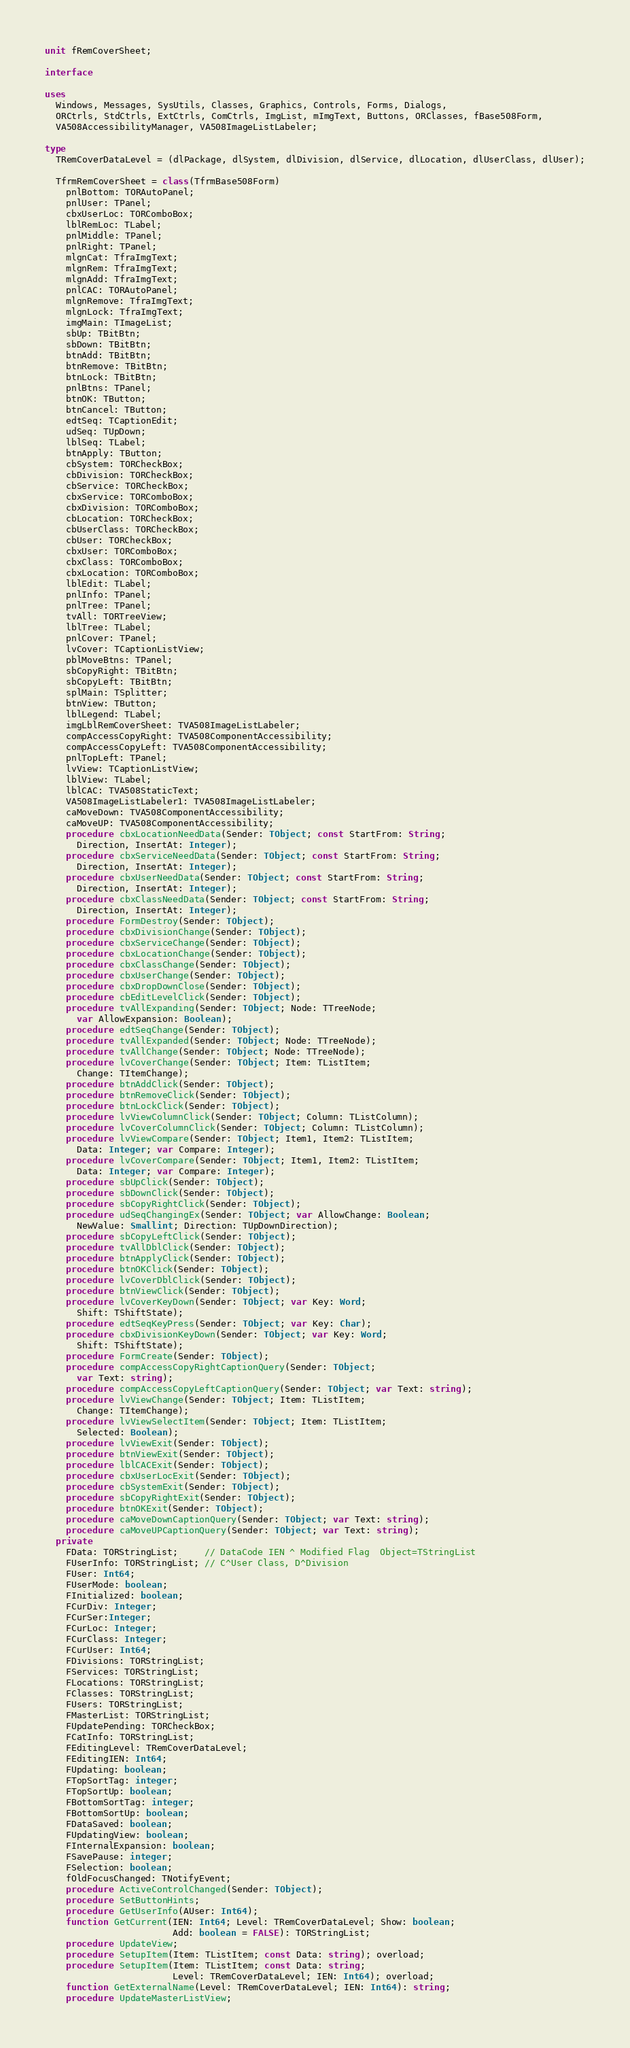Convert code to text. <code><loc_0><loc_0><loc_500><loc_500><_Pascal_>unit fRemCoverSheet;

interface

uses
  Windows, Messages, SysUtils, Classes, Graphics, Controls, Forms, Dialogs,
  ORCtrls, StdCtrls, ExtCtrls, ComCtrls, ImgList, mImgText, Buttons, ORClasses, fBase508Form,
  VA508AccessibilityManager, VA508ImageListLabeler;

type
  TRemCoverDataLevel = (dlPackage, dlSystem, dlDivision, dlService, dlLocation, dlUserClass, dlUser);

  TfrmRemCoverSheet = class(TfrmBase508Form)
    pnlBottom: TORAutoPanel;
    pnlUser: TPanel;
    cbxUserLoc: TORComboBox;
    lblRemLoc: TLabel;
    pnlMiddle: TPanel;
    pnlRight: TPanel;
    mlgnCat: TfraImgText;
    mlgnRem: TfraImgText;
    mlgnAdd: TfraImgText;
    pnlCAC: TORAutoPanel;
    mlgnRemove: TfraImgText;
    mlgnLock: TfraImgText;
    imgMain: TImageList;
    sbUp: TBitBtn;
    sbDown: TBitBtn;
    btnAdd: TBitBtn;
    btnRemove: TBitBtn;
    btnLock: TBitBtn;
    pnlBtns: TPanel;
    btnOK: TButton;
    btnCancel: TButton;
    edtSeq: TCaptionEdit;
    udSeq: TUpDown;
    lblSeq: TLabel;
    btnApply: TButton;
    cbSystem: TORCheckBox;
    cbDivision: TORCheckBox;
    cbService: TORCheckBox;
    cbxService: TORComboBox;
    cbxDivision: TORComboBox;
    cbLocation: TORCheckBox;
    cbUserClass: TORCheckBox;
    cbUser: TORCheckBox;
    cbxUser: TORComboBox;
    cbxClass: TORComboBox;
    cbxLocation: TORComboBox;
    lblEdit: TLabel;
    pnlInfo: TPanel;
    pnlTree: TPanel;
    tvAll: TORTreeView;
    lblTree: TLabel;
    pnlCover: TPanel;
    lvCover: TCaptionListView;
    pblMoveBtns: TPanel;
    sbCopyRight: TBitBtn;
    sbCopyLeft: TBitBtn;
    splMain: TSplitter;
    btnView: TButton;
    lblLegend: TLabel;
    imgLblRemCoverSheet: TVA508ImageListLabeler;
    compAccessCopyRight: TVA508ComponentAccessibility;
    compAccessCopyLeft: TVA508ComponentAccessibility;
    pnlTopLeft: TPanel;
    lvView: TCaptionListView;
    lblView: TLabel;
    lblCAC: TVA508StaticText;
    VA508ImageListLabeler1: TVA508ImageListLabeler;
    caMoveDown: TVA508ComponentAccessibility;
    caMoveUP: TVA508ComponentAccessibility;
    procedure cbxLocationNeedData(Sender: TObject; const StartFrom: String;
      Direction, InsertAt: Integer);
    procedure cbxServiceNeedData(Sender: TObject; const StartFrom: String;
      Direction, InsertAt: Integer);
    procedure cbxUserNeedData(Sender: TObject; const StartFrom: String;
      Direction, InsertAt: Integer);
    procedure cbxClassNeedData(Sender: TObject; const StartFrom: String;
      Direction, InsertAt: Integer);
    procedure FormDestroy(Sender: TObject);
    procedure cbxDivisionChange(Sender: TObject);
    procedure cbxServiceChange(Sender: TObject);
    procedure cbxLocationChange(Sender: TObject);
    procedure cbxClassChange(Sender: TObject);
    procedure cbxUserChange(Sender: TObject);
    procedure cbxDropDownClose(Sender: TObject);
    procedure cbEditLevelClick(Sender: TObject);
    procedure tvAllExpanding(Sender: TObject; Node: TTreeNode;
      var AllowExpansion: Boolean);
    procedure edtSeqChange(Sender: TObject);
    procedure tvAllExpanded(Sender: TObject; Node: TTreeNode);
    procedure tvAllChange(Sender: TObject; Node: TTreeNode);
    procedure lvCoverChange(Sender: TObject; Item: TListItem;
      Change: TItemChange);
    procedure btnAddClick(Sender: TObject);
    procedure btnRemoveClick(Sender: TObject);
    procedure btnLockClick(Sender: TObject);
    procedure lvViewColumnClick(Sender: TObject; Column: TListColumn);
    procedure lvCoverColumnClick(Sender: TObject; Column: TListColumn);
    procedure lvViewCompare(Sender: TObject; Item1, Item2: TListItem;
      Data: Integer; var Compare: Integer);
    procedure lvCoverCompare(Sender: TObject; Item1, Item2: TListItem;
      Data: Integer; var Compare: Integer);
    procedure sbUpClick(Sender: TObject);
    procedure sbDownClick(Sender: TObject);
    procedure sbCopyRightClick(Sender: TObject);
    procedure udSeqChangingEx(Sender: TObject; var AllowChange: Boolean;
      NewValue: Smallint; Direction: TUpDownDirection);
    procedure sbCopyLeftClick(Sender: TObject);
    procedure tvAllDblClick(Sender: TObject);
    procedure btnApplyClick(Sender: TObject);
    procedure btnOKClick(Sender: TObject);
    procedure lvCoverDblClick(Sender: TObject);
    procedure btnViewClick(Sender: TObject);
    procedure lvCoverKeyDown(Sender: TObject; var Key: Word;
      Shift: TShiftState);
    procedure edtSeqKeyPress(Sender: TObject; var Key: Char);
    procedure cbxDivisionKeyDown(Sender: TObject; var Key: Word;
      Shift: TShiftState);
    procedure FormCreate(Sender: TObject);
    procedure compAccessCopyRightCaptionQuery(Sender: TObject;
      var Text: string);
    procedure compAccessCopyLeftCaptionQuery(Sender: TObject; var Text: string);
    procedure lvViewChange(Sender: TObject; Item: TListItem;
      Change: TItemChange);
    procedure lvViewSelectItem(Sender: TObject; Item: TListItem;
      Selected: Boolean);
    procedure lvViewExit(Sender: TObject);
    procedure btnViewExit(Sender: TObject);
    procedure lblCACExit(Sender: TObject);
    procedure cbxUserLocExit(Sender: TObject);
    procedure cbSystemExit(Sender: TObject);
    procedure sbCopyRightExit(Sender: TObject);
    procedure btnOKExit(Sender: TObject);
    procedure caMoveDownCaptionQuery(Sender: TObject; var Text: string);
    procedure caMoveUPCaptionQuery(Sender: TObject; var Text: string);
  private
    FData: TORStringList;     // DataCode IEN ^ Modified Flag  Object=TStringList
    FUserInfo: TORStringList; // C^User Class, D^Division
    FUser: Int64;
    FUserMode: boolean;
    FInitialized: boolean;
    FCurDiv: Integer;
    FCurSer:Integer;
    FCurLoc: Integer;
    FCurClass: Integer;
    FCurUser: Int64;
    FDivisions: TORStringList;
    FServices: TORStringList;
    FLocations: TORStringList;
    FClasses: TORStringList;
    FUsers: TORStringList;
    FMasterList: TORStringList;
    FUpdatePending: TORCheckBox;
    FCatInfo: TORStringList;
    FEditingLevel: TRemCoverDataLevel;
    FEditingIEN: Int64;
    FUpdating: boolean;
    FTopSortTag: integer;
    FTopSortUp: boolean;
    FBottomSortTag: integer;
    FBottomSortUp: boolean;
    FDataSaved: boolean;
    FUpdatingView: boolean;
    FInternalExpansion: boolean;
    FSavePause: integer;
    FSelection: boolean;
    fOldFocusChanged: TNotifyEvent;
    procedure ActiveControlChanged(Sender: TObject);
    procedure SetButtonHints;
    procedure GetUserInfo(AUser: Int64);
    function GetCurrent(IEN: Int64; Level: TRemCoverDataLevel; Show: boolean;
                        Add: boolean = FALSE): TORStringList;
    procedure UpdateView;
    procedure SetupItem(Item: TListItem; const Data: string); overload;
    procedure SetupItem(Item: TListItem; const Data: string;
                        Level: TRemCoverDataLevel; IEN: Int64); overload;
    function GetExternalName(Level: TRemCoverDataLevel; IEN: Int64): string;
    procedure UpdateMasterListView;</code> 